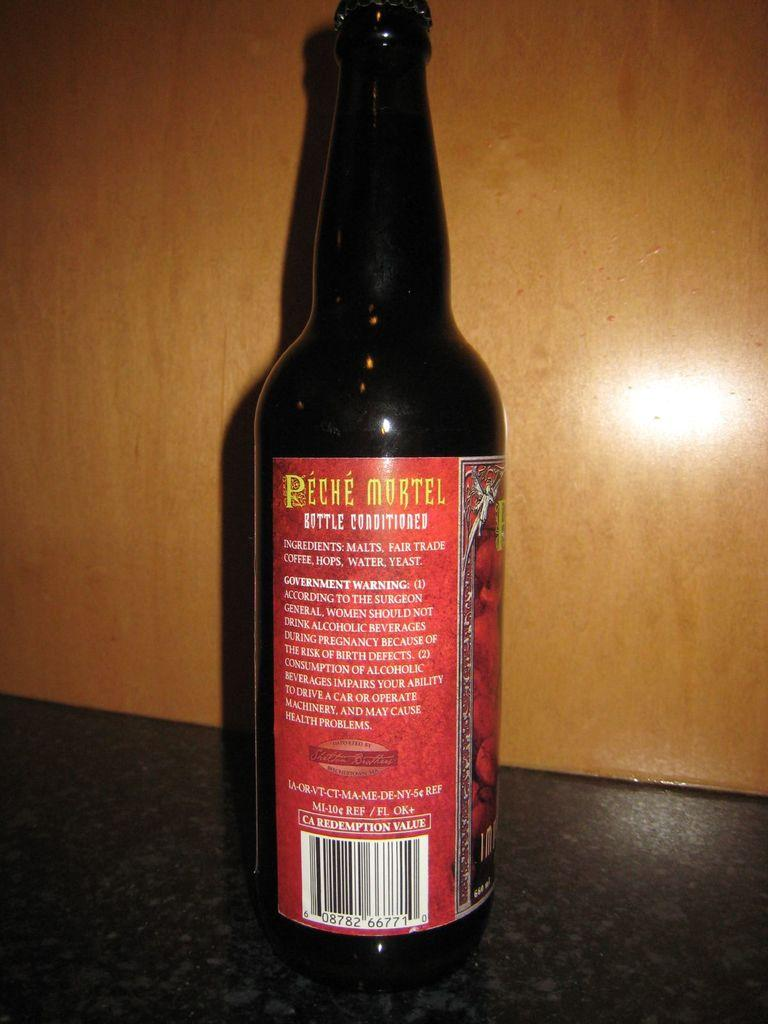What object can be seen in the image? There is a bottle in the image. What is on the bottle? The bottle has a sticker on it. What can be seen in the background of the image? There is a wall in the background of the image. What type of seed is growing on the wall in the image? There is no seed or plant growing on the wall in the image; it only shows a bottle with a sticker and a wall in the background. 